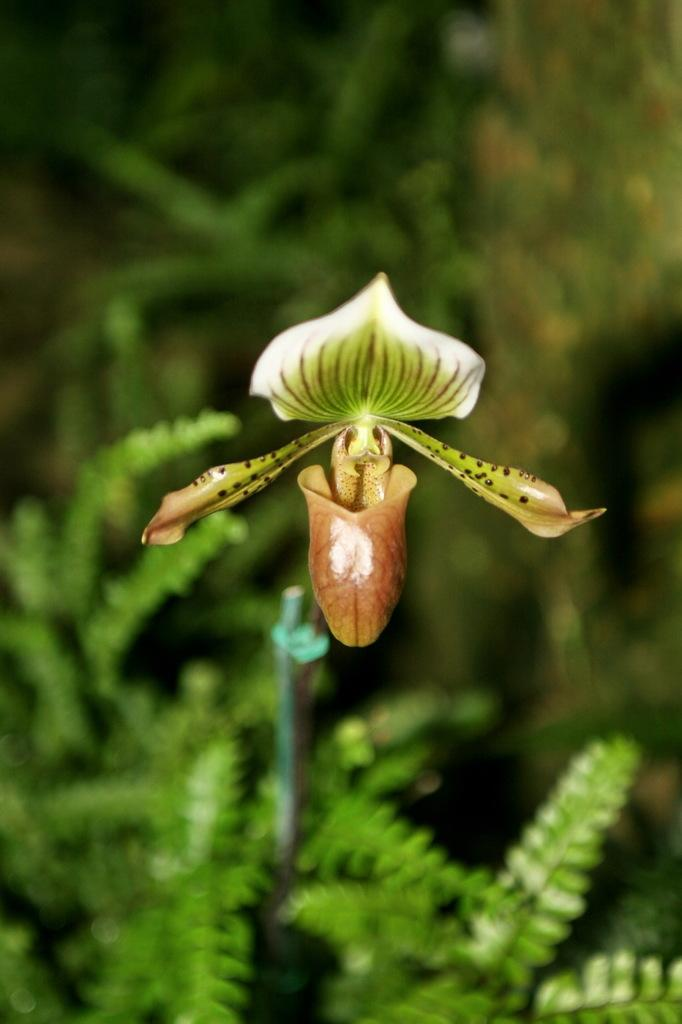What is the main subject of the image? There is a flower in the center of the image. What can be seen in the background of the image? There is greenery in the background of the image. What type of yarn is being used to create the flower in the image? There is no yarn present in the image; the flower is a real one. What is the income of the person who took the picture of the flower? The income of the person who took the picture is not mentioned or visible in the image. 